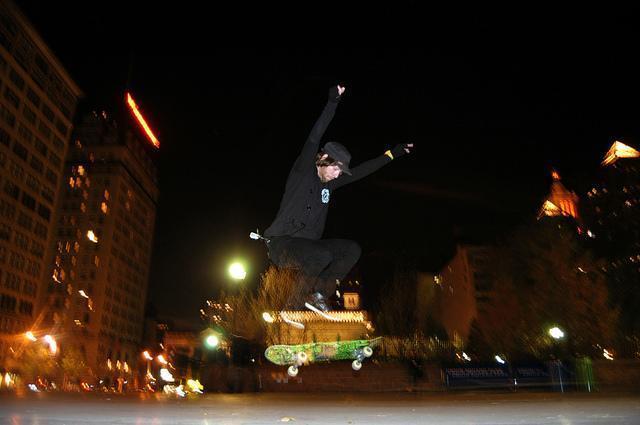How many people can you see?
Give a very brief answer. 1. 